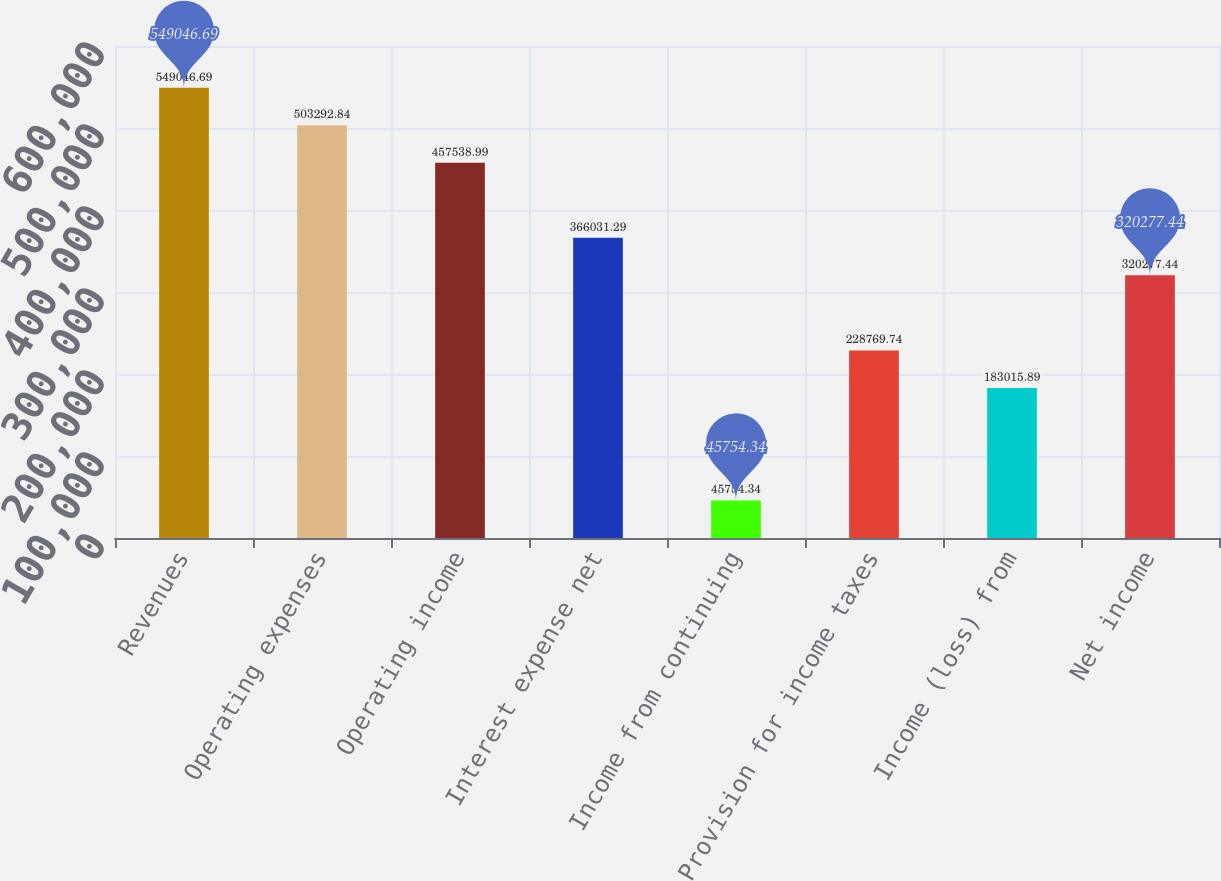Convert chart. <chart><loc_0><loc_0><loc_500><loc_500><bar_chart><fcel>Revenues<fcel>Operating expenses<fcel>Operating income<fcel>Interest expense net<fcel>Income from continuing<fcel>Provision for income taxes<fcel>Income (loss) from<fcel>Net income<nl><fcel>549047<fcel>503293<fcel>457539<fcel>366031<fcel>45754.3<fcel>228770<fcel>183016<fcel>320277<nl></chart> 